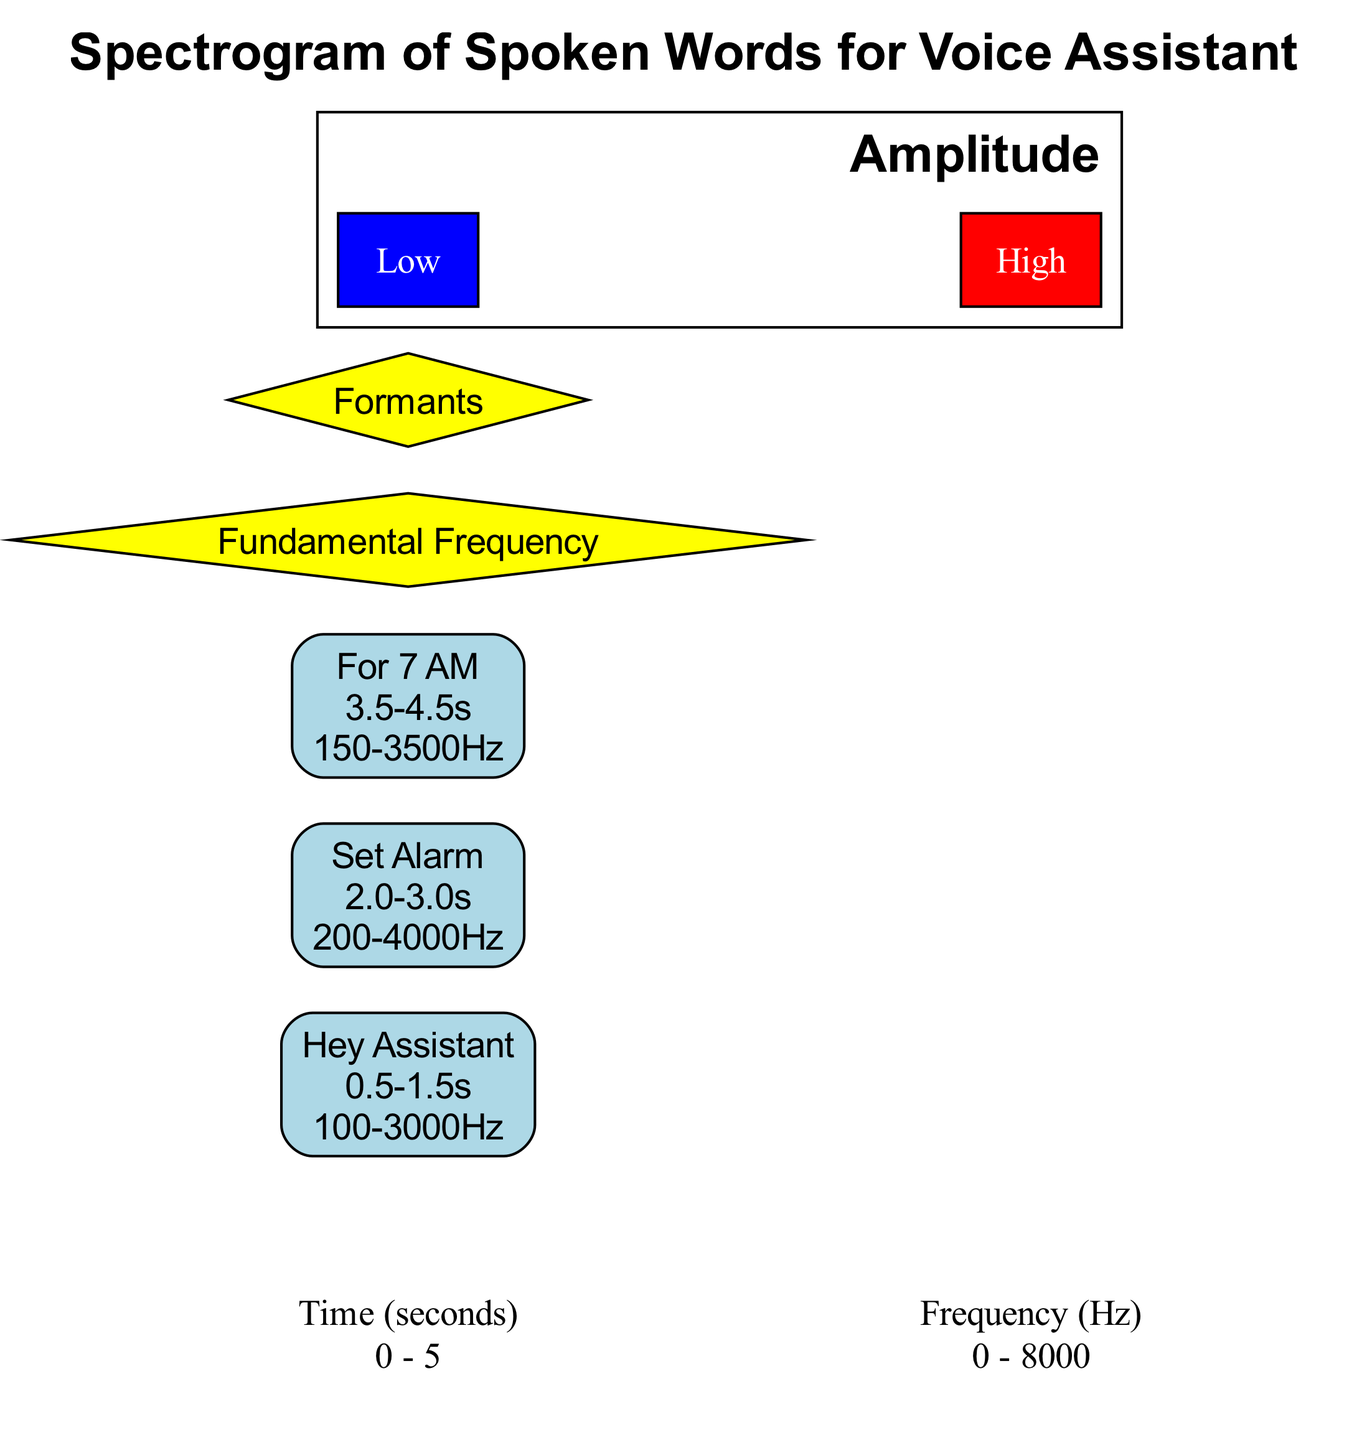What is the time range for "Set Alarm"? The time range for "Set Alarm" is specified in its region information. The time range is indicated as [2.0, 3.0].
Answer: 2.0 - 3.0 What frequency range does the region "Hey Assistant" cover? The frequency range for "Hey Assistant" is given in the region details as [100, 3000] Hz.
Answer: 100 - 3000 Hz How many regions are displayed in the spectrogram? By counting the number of distinct regions labeled in the diagram, there are three regions: "Hey Assistant," "Set Alarm," and "For 7 AM."
Answer: 3 What is the position of the "Fundamental Frequency" marker? The "Fundamental Frequency" marker's position is represented in the diagram, where the coordinates [2.5, 200] indicate its location.
Answer: 2.5, 200 Which region has the highest frequency range? To determine this, we compare the frequency ranges of all regions. The region "Set Alarm" has a frequency range of [200, 4000], which is higher than the ranges of the other regions.
Answer: Set Alarm What color represents high amplitude in the color scale? The color scale indicates that high amplitude is represented in red according to the specifics outlined in the color scale information.
Answer: Red Which marker has a position of [3.0, 2000]? From the diagram details, the marker at position [3.0, 2000] is labeled as "Formants."
Answer: Formants How does the amplitude scale change from low to high? The amplitude scale transitions from blue, representing low amplitude, to red, which is used to signify high amplitude, as indicated in the color scale.
Answer: Blue to Red What is the frequency range for the phrase "For 7 AM"? The frequency range for the phrase "For 7 AM" is specified in the region's details as [150, 3500] Hz.
Answer: 150 - 3500 Hz Which word is spoken between the times 0.5 and 1.5 seconds? The region between the times 0.5 and 1.5 seconds is labeled "Hey Assistant," indicating the word spoken during that timeframe.
Answer: Hey Assistant 